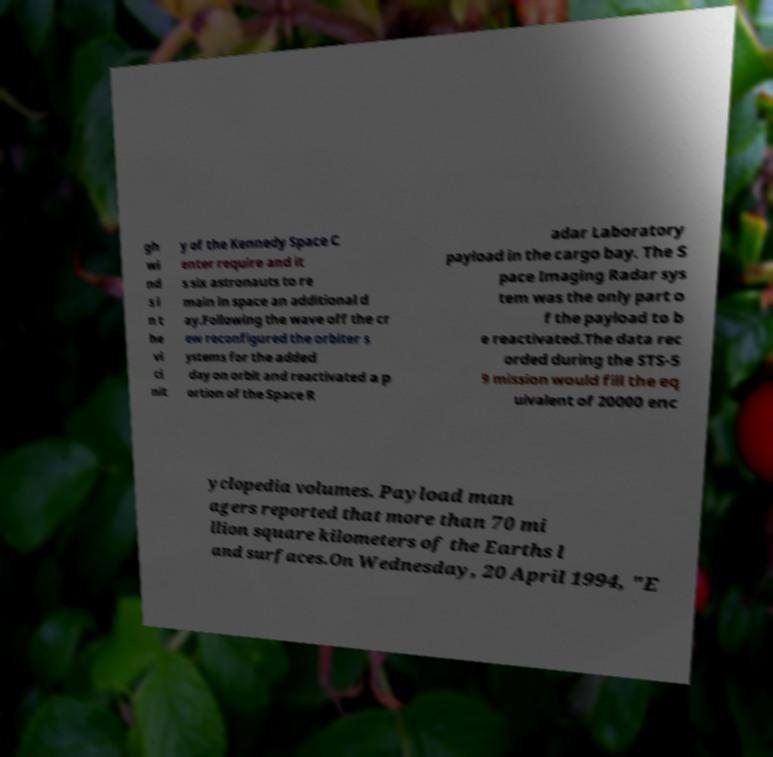I need the written content from this picture converted into text. Can you do that? gh wi nd s i n t he vi ci nit y of the Kennedy Space C enter require and it s six astronauts to re main in space an additional d ay.Following the wave off the cr ew reconfigured the orbiter s ystems for the added day on orbit and reactivated a p ortion of the Space R adar Laboratory payload in the cargo bay. The S pace Imaging Radar sys tem was the only part o f the payload to b e reactivated.The data rec orded during the STS-5 9 mission would fill the eq uivalent of 20000 enc yclopedia volumes. Payload man agers reported that more than 70 mi llion square kilometers of the Earths l and surfaces.On Wednesday, 20 April 1994, "E 